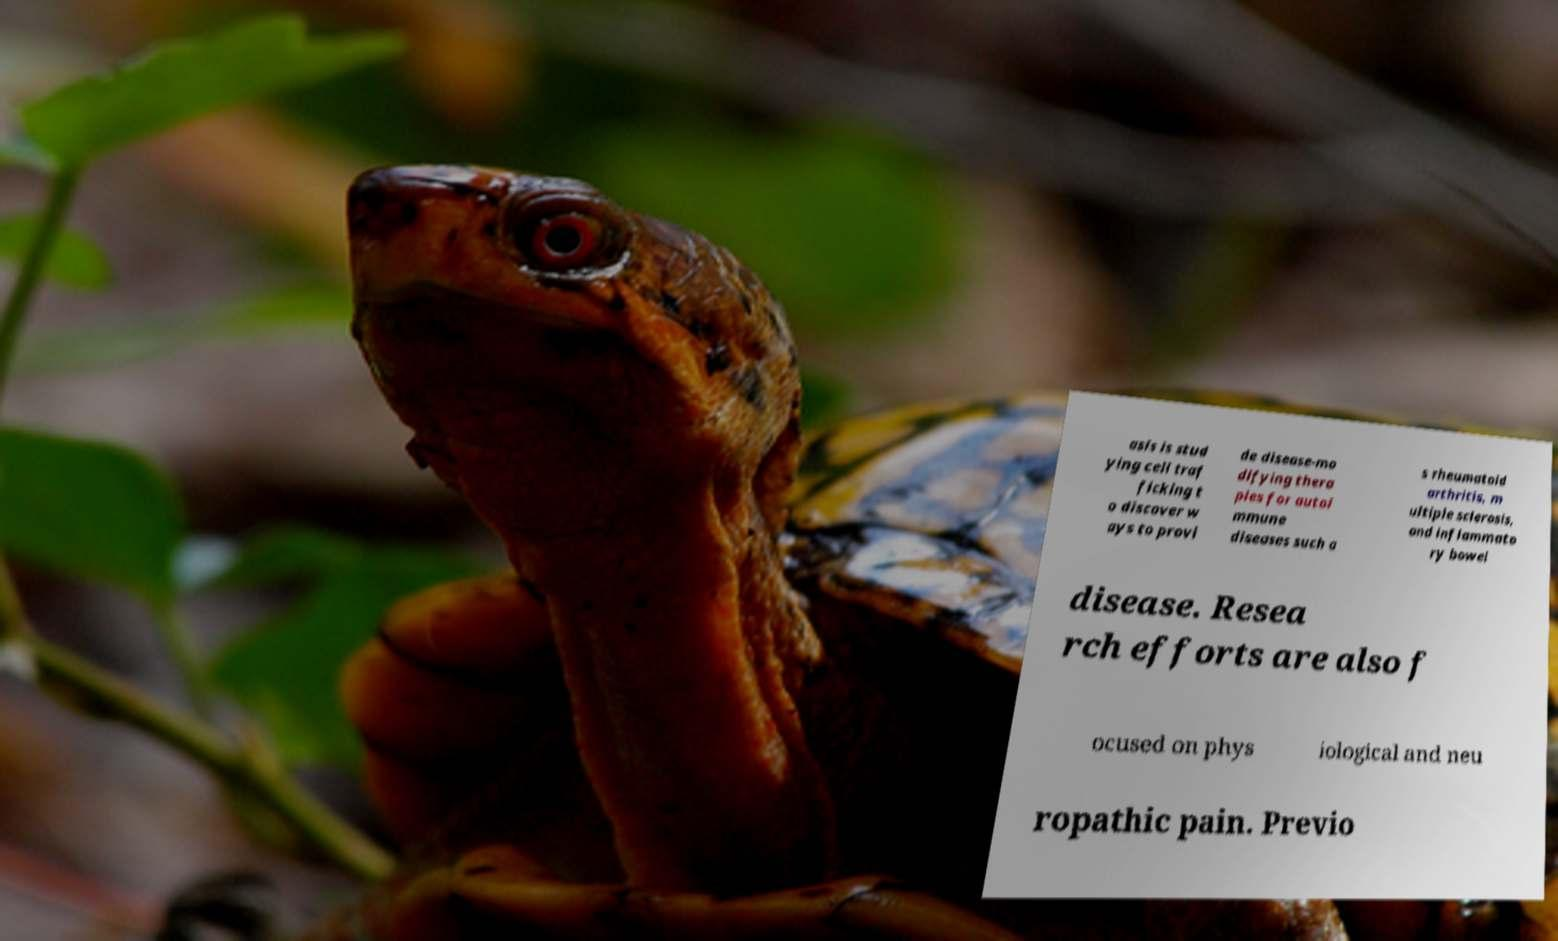What messages or text are displayed in this image? I need them in a readable, typed format. asis is stud ying cell traf ficking t o discover w ays to provi de disease-mo difying thera pies for autoi mmune diseases such a s rheumatoid arthritis, m ultiple sclerosis, and inflammato ry bowel disease. Resea rch efforts are also f ocused on phys iological and neu ropathic pain. Previo 